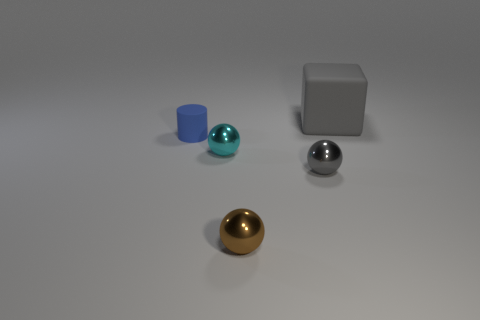How many rubber objects are behind the tiny rubber thing?
Keep it short and to the point. 1. How many tiny rubber things have the same color as the matte block?
Offer a terse response. 0. Is the number of blue metallic cylinders greater than the number of tiny shiny balls?
Provide a succinct answer. No. There is a object that is both right of the small brown ball and in front of the big gray object; how big is it?
Offer a very short reply. Small. Is the gray thing that is to the left of the large block made of the same material as the object left of the tiny cyan thing?
Keep it short and to the point. No. What shape is the brown object that is the same size as the blue object?
Make the answer very short. Sphere. Are there fewer small brown metal spheres than small metallic balls?
Provide a succinct answer. Yes. There is a rubber object that is in front of the large gray rubber thing; is there a gray thing behind it?
Offer a very short reply. Yes. There is a rubber thing left of the small sphere that is on the right side of the brown object; is there a sphere behind it?
Keep it short and to the point. No. Does the matte object that is in front of the matte block have the same shape as the gray thing in front of the big gray thing?
Offer a very short reply. No. 